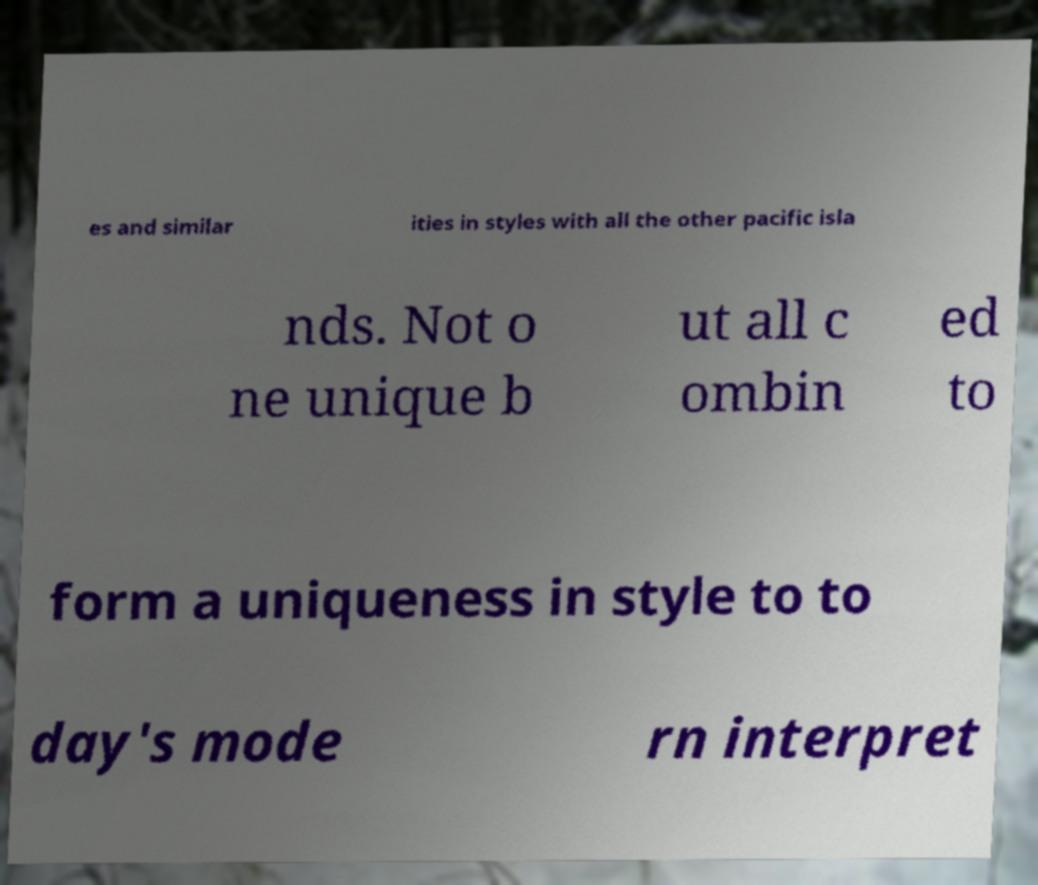Please identify and transcribe the text found in this image. es and similar ities in styles with all the other pacific isla nds. Not o ne unique b ut all c ombin ed to form a uniqueness in style to to day's mode rn interpret 